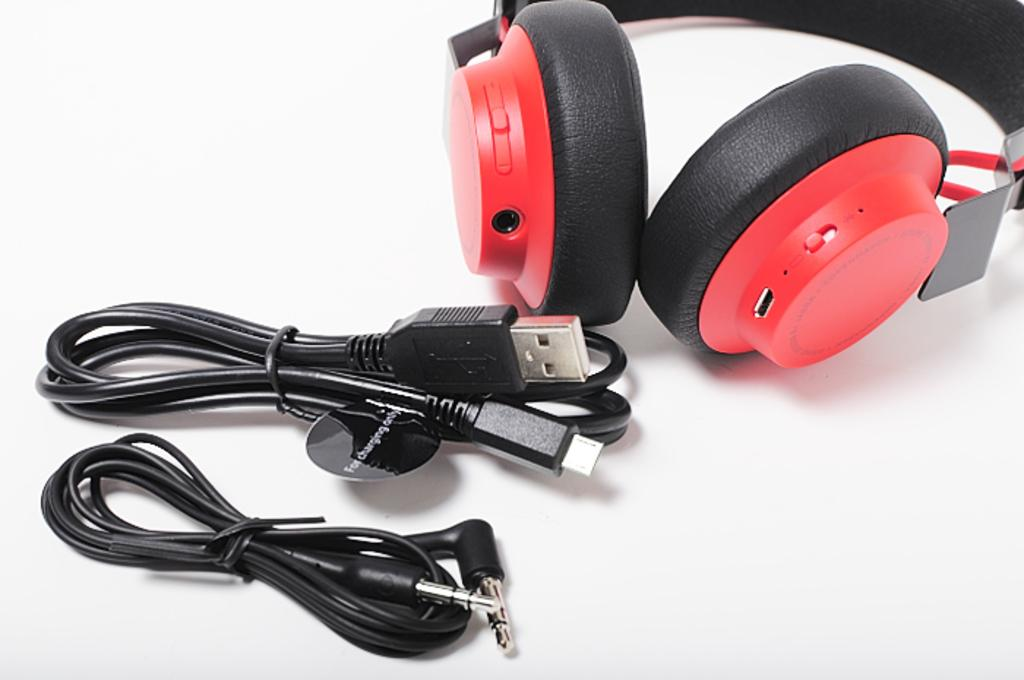What is placed on the table in the image? There are headphones on the table. What else can be seen near the headphones? There are cables beside the headphones. How does the person in the image react to the payment for the headphones? There is no person present in the image, and therefore no reaction to a payment can be observed. 